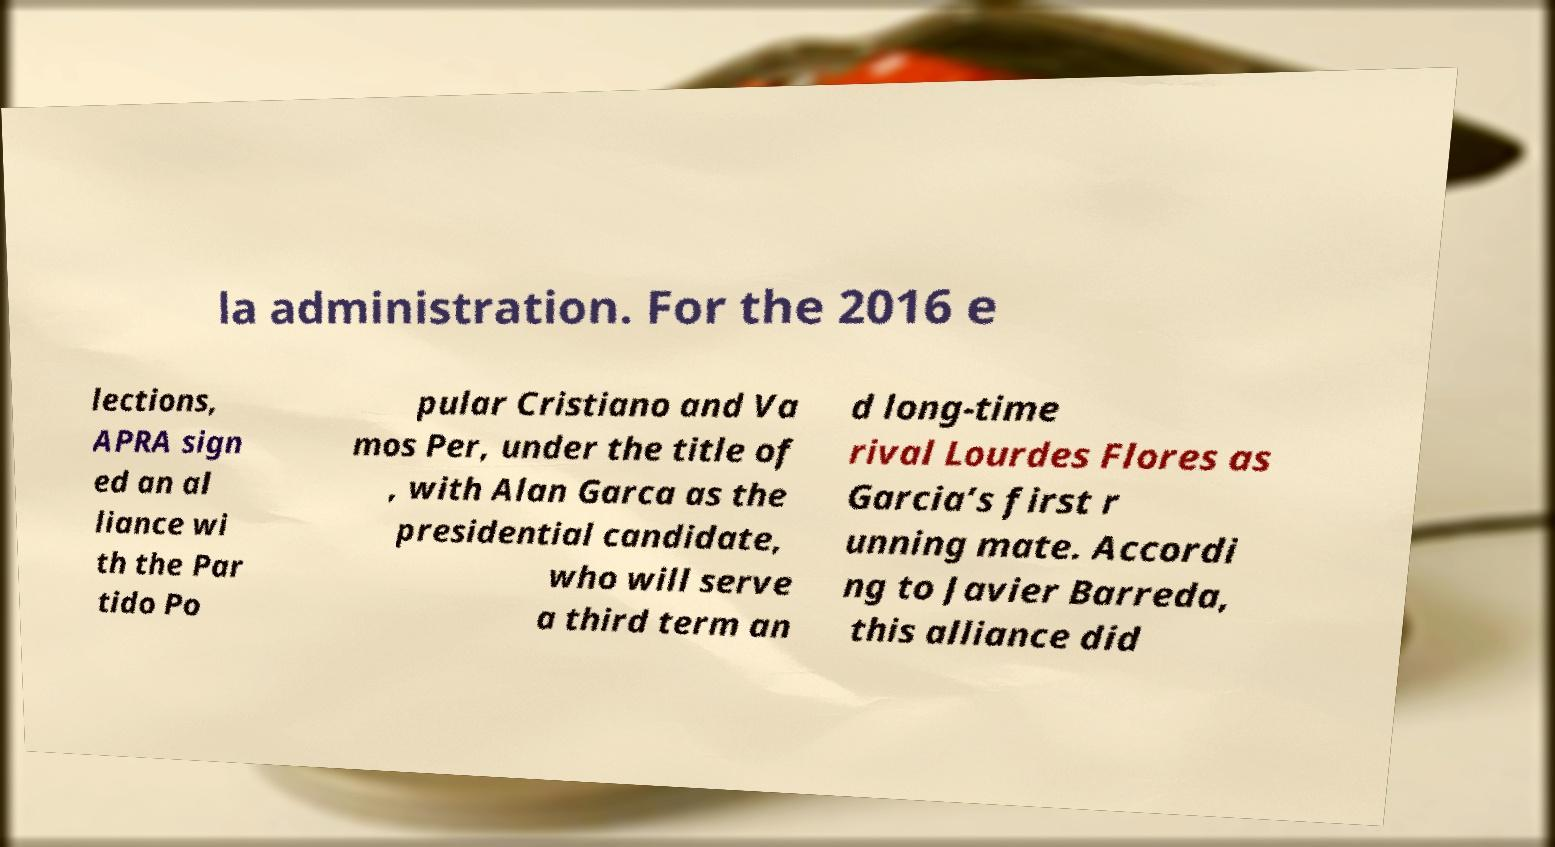Can you read and provide the text displayed in the image?This photo seems to have some interesting text. Can you extract and type it out for me? la administration. For the 2016 e lections, APRA sign ed an al liance wi th the Par tido Po pular Cristiano and Va mos Per, under the title of , with Alan Garca as the presidential candidate, who will serve a third term an d long-time rival Lourdes Flores as Garcia’s first r unning mate. Accordi ng to Javier Barreda, this alliance did 